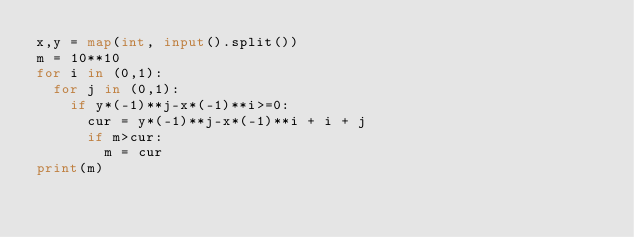<code> <loc_0><loc_0><loc_500><loc_500><_Python_>x,y = map(int, input().split())
m = 10**10
for i in (0,1):
  for j in (0,1):
    if y*(-1)**j-x*(-1)**i>=0:
      cur = y*(-1)**j-x*(-1)**i + i + j
      if m>cur:
        m = cur
print(m)</code> 